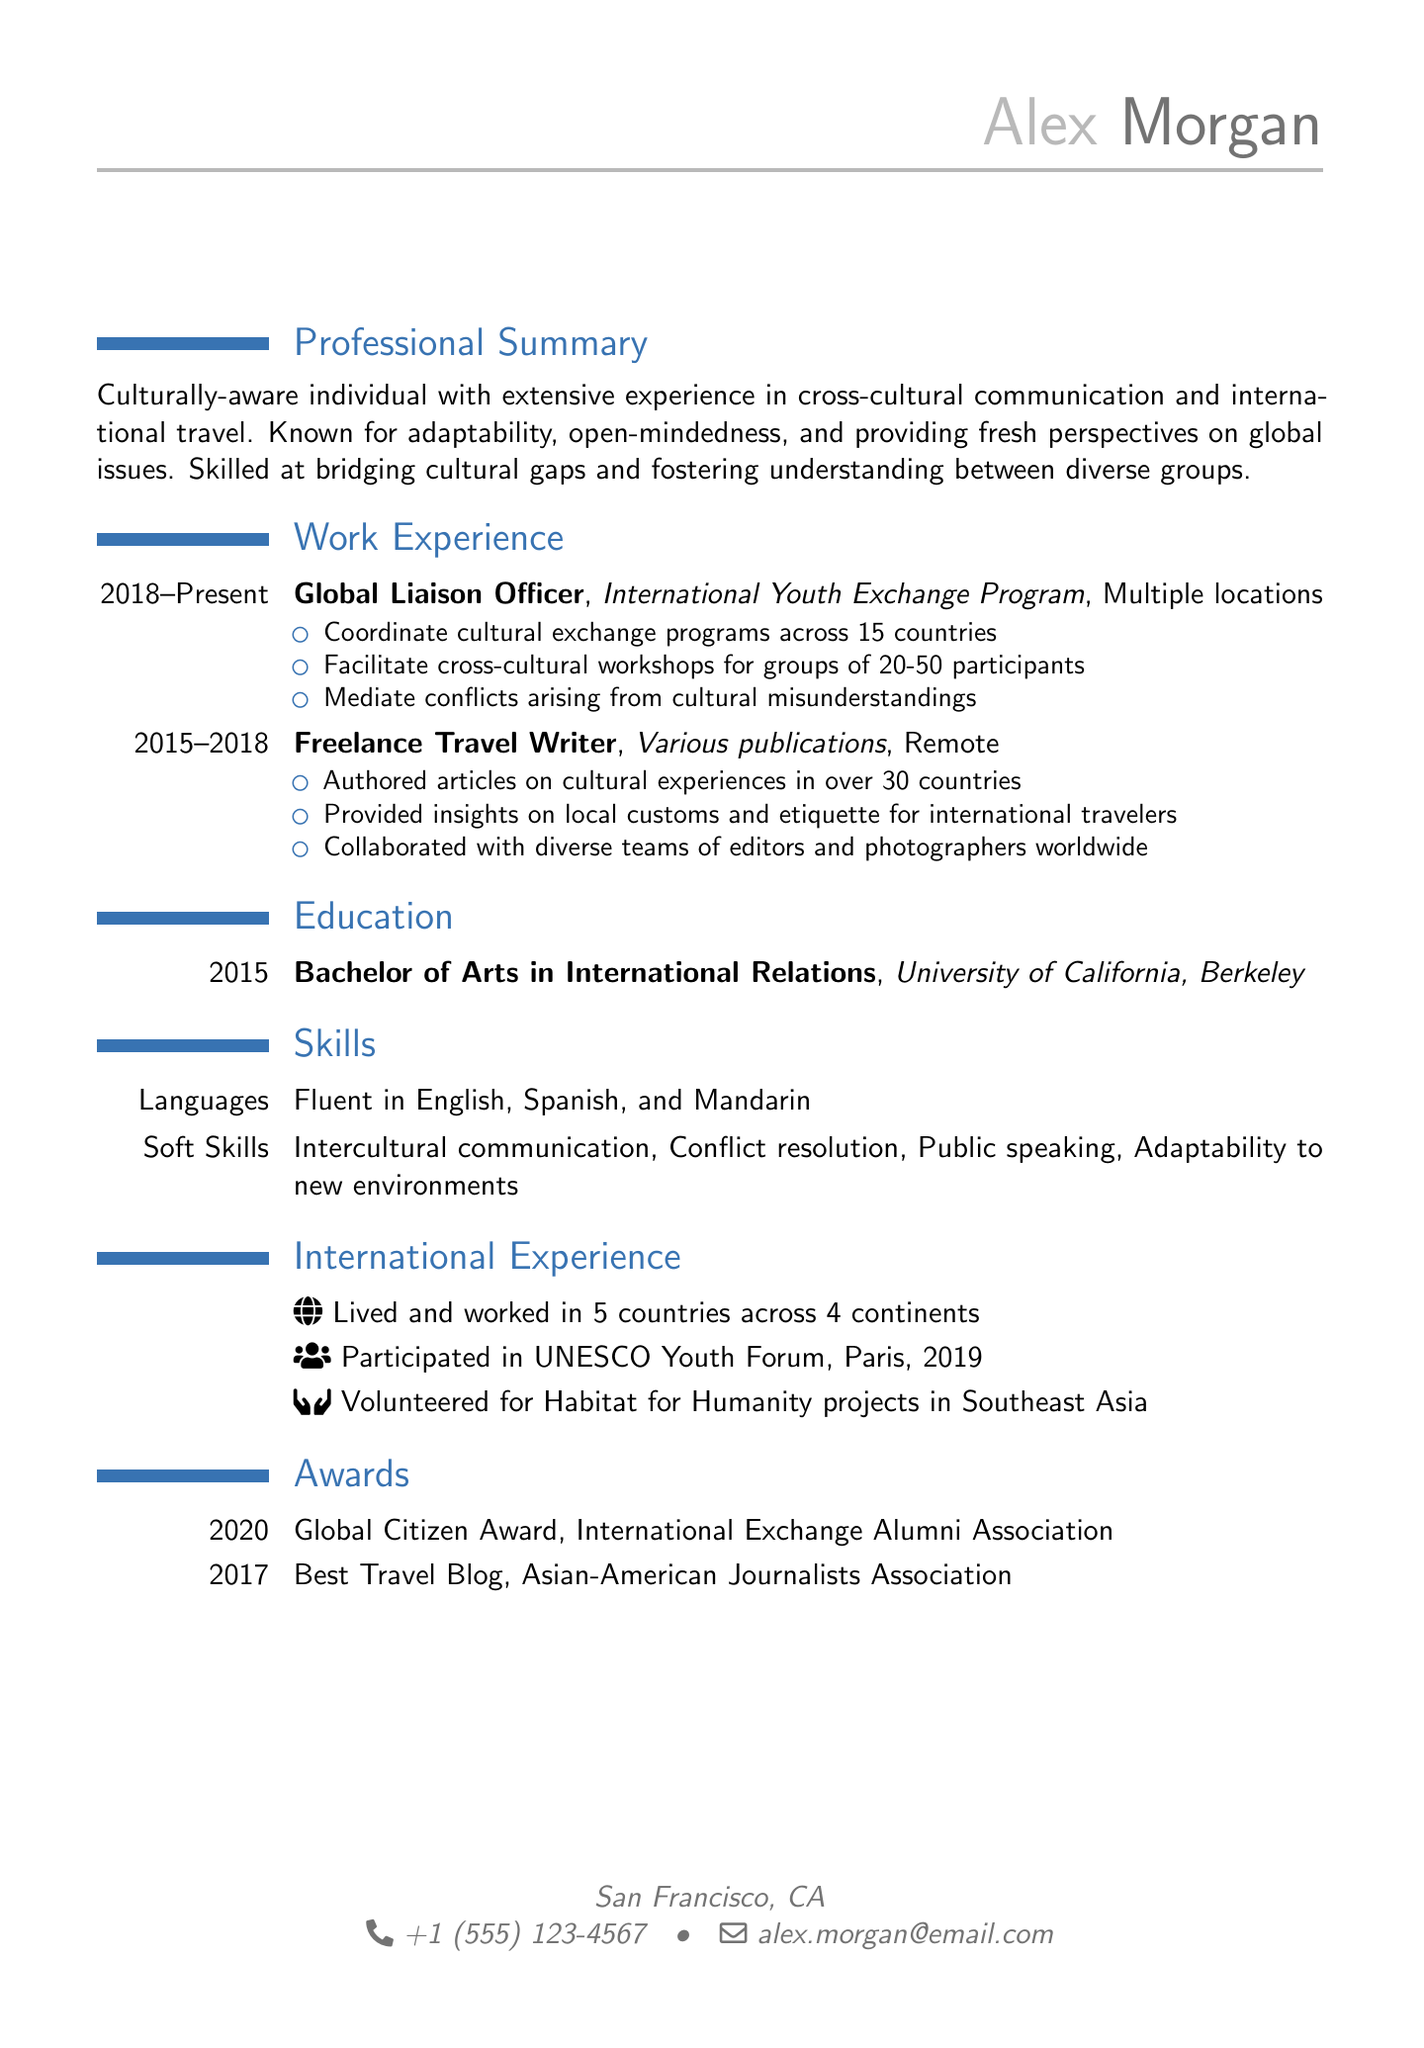what is the name of the individual? The name presented in the document is mentioned in the personal details section.
Answer: Alex Morgan what is Alex's email address? The email address is listed under personal details.
Answer: alex.morgan@email.com how many countries has Alex lived and worked in? This information is found in the international experience section.
Answer: 5 what was Alex’s job title at the International Youth Exchange Program? The job title can be found in the work experience section.
Answer: Global Liaison Officer what award did Alex receive in 2020? The award details are provided in the awards section.
Answer: Global Citizen Award which university did Alex graduate from? The university name is mentioned in the education section.
Answer: University of California, Berkeley what skill is related to working with diverse groups? The skills section lists various abilities relevant to the position described.
Answer: Intercultural communication how many countries did Alex write about as a freelance travel writer? The number of countries is mentioned in the responsibilities of the freelance travel writer role.
Answer: 30 in which year did Alex participate in the UNESCO Youth Forum? This event is listed under international experience.
Answer: 2019 